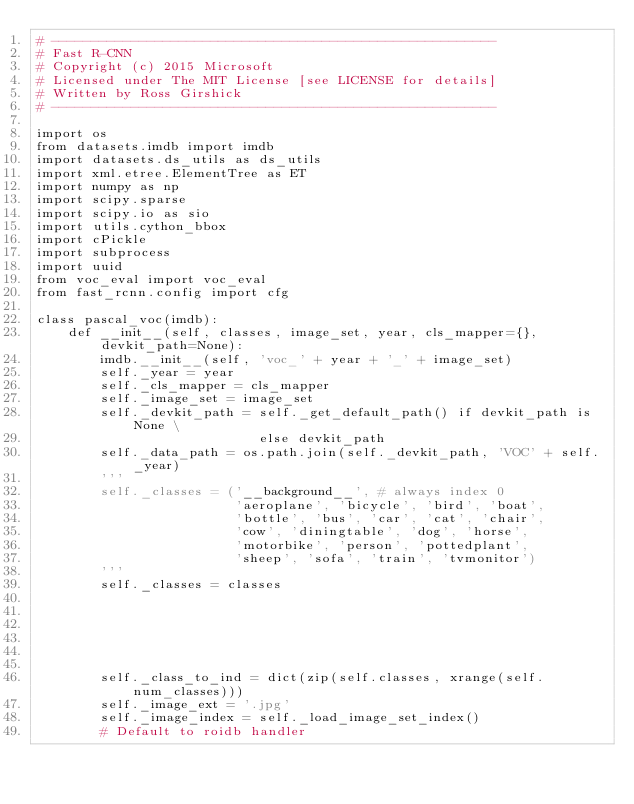<code> <loc_0><loc_0><loc_500><loc_500><_Python_># --------------------------------------------------------
# Fast R-CNN
# Copyright (c) 2015 Microsoft
# Licensed under The MIT License [see LICENSE for details]
# Written by Ross Girshick
# --------------------------------------------------------

import os
from datasets.imdb import imdb
import datasets.ds_utils as ds_utils
import xml.etree.ElementTree as ET
import numpy as np
import scipy.sparse
import scipy.io as sio
import utils.cython_bbox
import cPickle
import subprocess
import uuid
from voc_eval import voc_eval
from fast_rcnn.config import cfg

class pascal_voc(imdb):
    def __init__(self, classes, image_set, year, cls_mapper={}, devkit_path=None):
        imdb.__init__(self, 'voc_' + year + '_' + image_set)
        self._year = year
        self._cls_mapper = cls_mapper
        self._image_set = image_set
        self._devkit_path = self._get_default_path() if devkit_path is None \
                            else devkit_path
        self._data_path = os.path.join(self._devkit_path, 'VOC' + self._year)
        '''
        self._classes = ('__background__', # always index 0
                         'aeroplane', 'bicycle', 'bird', 'boat',
                         'bottle', 'bus', 'car', 'cat', 'chair',
                         'cow', 'diningtable', 'dog', 'horse',
                         'motorbike', 'person', 'pottedplant',
                         'sheep', 'sofa', 'train', 'tvmonitor')
        '''
        self._classes = classes
        
        
        
        
        
        
        self._class_to_ind = dict(zip(self.classes, xrange(self.num_classes)))
        self._image_ext = '.jpg'
        self._image_index = self._load_image_set_index()
        # Default to roidb handler</code> 